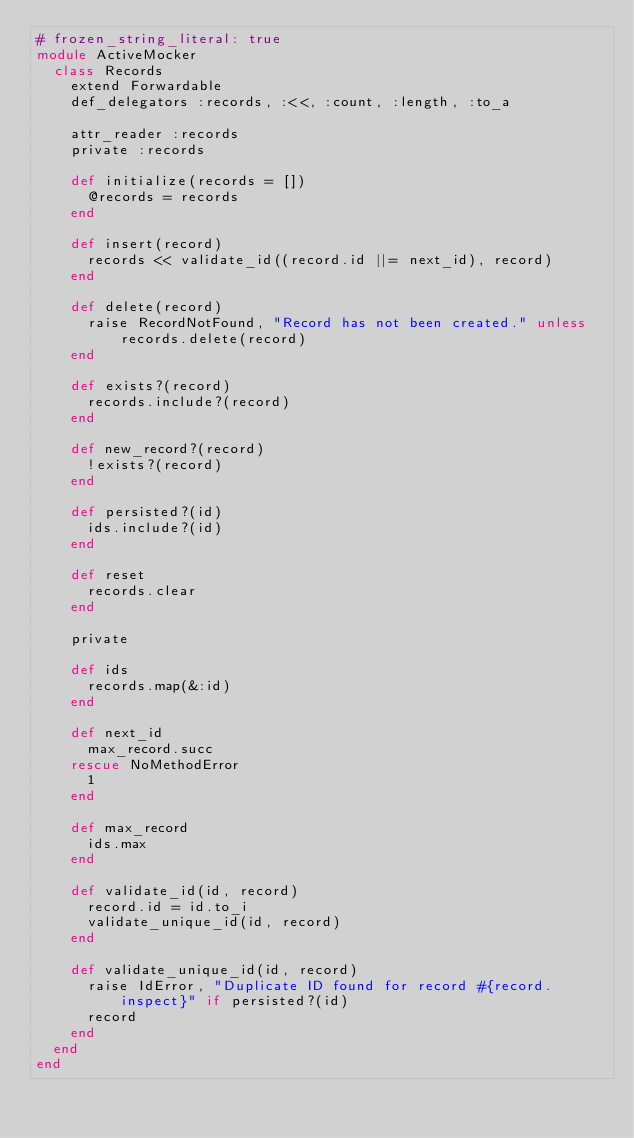<code> <loc_0><loc_0><loc_500><loc_500><_Ruby_># frozen_string_literal: true
module ActiveMocker
  class Records
    extend Forwardable
    def_delegators :records, :<<, :count, :length, :to_a

    attr_reader :records
    private :records

    def initialize(records = [])
      @records = records
    end

    def insert(record)
      records << validate_id((record.id ||= next_id), record)
    end

    def delete(record)
      raise RecordNotFound, "Record has not been created." unless records.delete(record)
    end

    def exists?(record)
      records.include?(record)
    end

    def new_record?(record)
      !exists?(record)
    end

    def persisted?(id)
      ids.include?(id)
    end

    def reset
      records.clear
    end

    private

    def ids
      records.map(&:id)
    end

    def next_id
      max_record.succ
    rescue NoMethodError
      1
    end

    def max_record
      ids.max
    end

    def validate_id(id, record)
      record.id = id.to_i
      validate_unique_id(id, record)
    end

    def validate_unique_id(id, record)
      raise IdError, "Duplicate ID found for record #{record.inspect}" if persisted?(id)
      record
    end
  end
end
</code> 